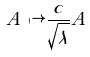<formula> <loc_0><loc_0><loc_500><loc_500>A \mapsto \frac { c } { \sqrt { \lambda } } A</formula> 